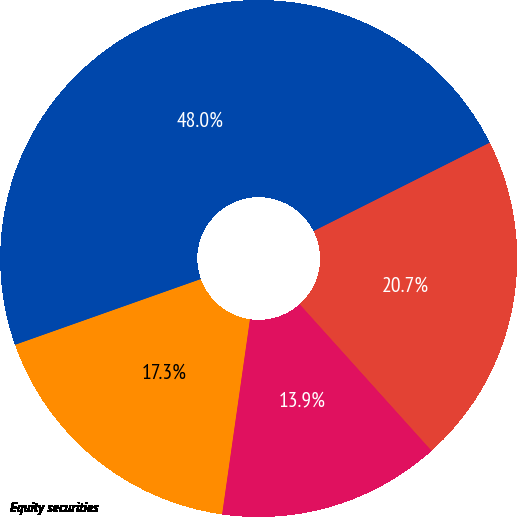Convert chart to OTSL. <chart><loc_0><loc_0><loc_500><loc_500><pie_chart><fcel>Equity securities<fcel>Debt securities<fcel>Other<fcel>Total<nl><fcel>17.33%<fcel>13.92%<fcel>20.74%<fcel>48.01%<nl></chart> 